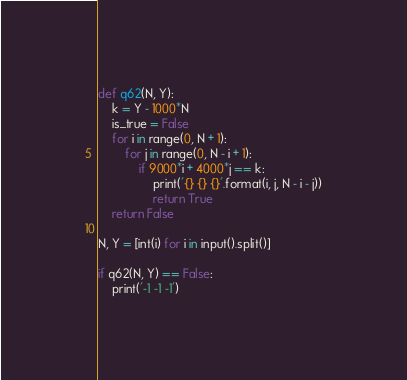<code> <loc_0><loc_0><loc_500><loc_500><_Python_>def q62(N, Y):
    k = Y - 1000*N
    is_true = False
    for i in range(0, N + 1):
        for j in range(0, N - i + 1):
            if 9000*i + 4000*j == k:
                print('{} {} {}'.format(i, j, N - i - j))
                return True
    return False

N, Y = [int(i) for i in input().split()]

if q62(N, Y) == False:
    print('-1 -1 -1')</code> 